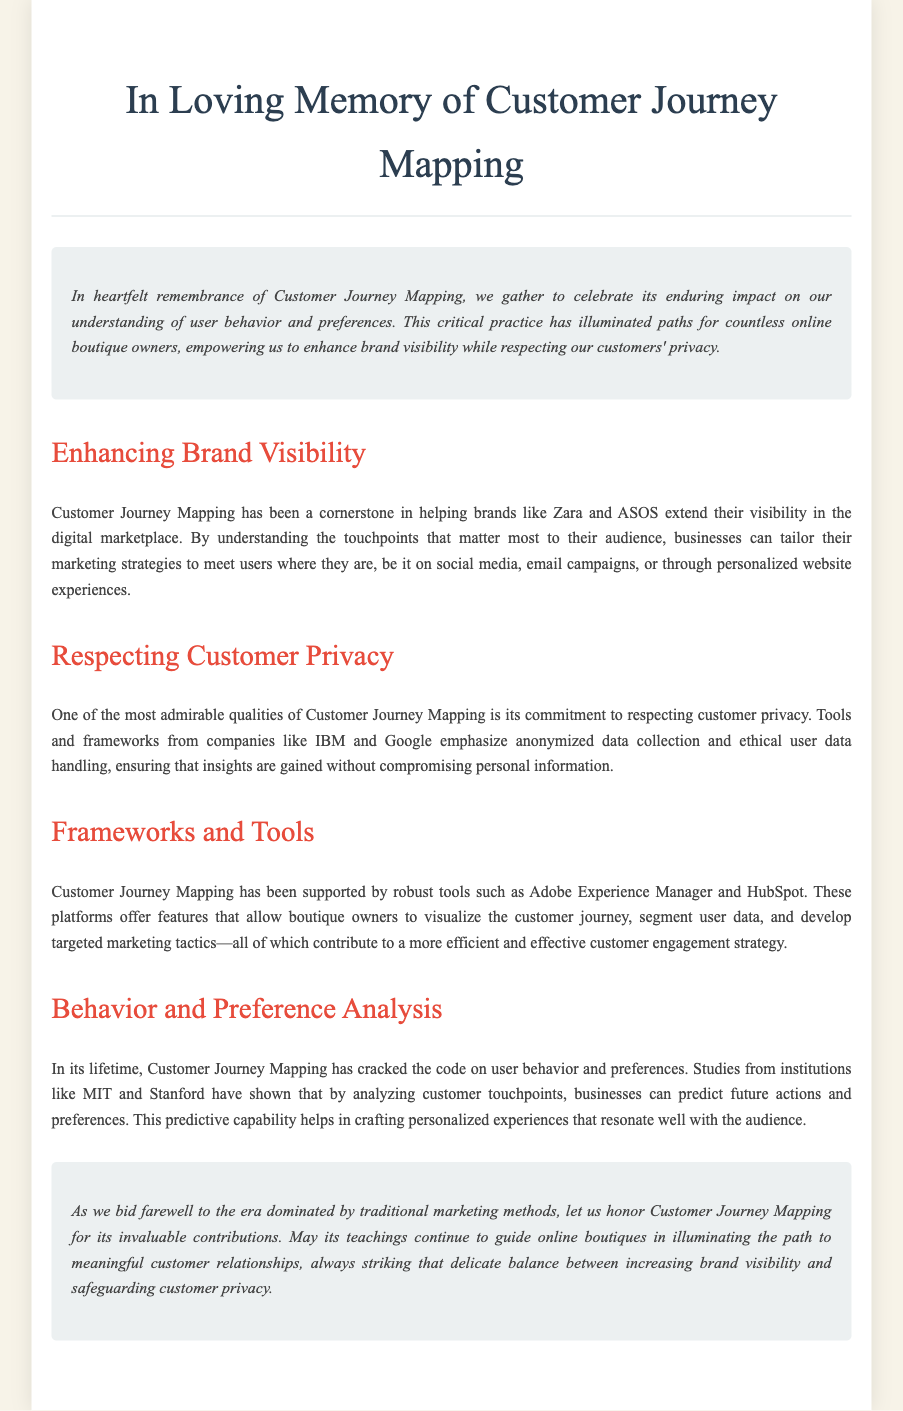what is the title of the document? The title of the document is displayed prominently at the top of the rendered content.
Answer: In Loving Memory of Customer Journey Mapping who are mentioned as companies that support Customer Journey Mapping? The document lists specific companies that play a role in Customer Journey Mapping, focusing on their contributions.
Answer: IBM and Google what is highlighted as a key aspect of Customer Journey Mapping? The text emphasizes the importance of respecting customer privacy as a major feature of Customer Journey Mapping.
Answer: Respecting customer privacy which platforms are mentioned that assist boutique owners? The document identifies specific platforms that provide tools and features for visualizing customer journeys.
Answer: Adobe Experience Manager and HubSpot what has Customer Journey Mapping helped businesses predict? The document discusses the analysis of user behavior and preferences enabled by Customer Journey Mapping.
Answer: Future actions and preferences what type of marketing methods does the document suggest has become less dominant? The conclusion reflects on the transition from traditional marketing methods to modern strategies.
Answer: Traditional marketing methods how does the document describe the impact of Customer Journey Mapping? The introduction provides insight into the lasting influence Customer Journey Mapping has had on online boutique owners.
Answer: Enduring impact on our understanding of user behavior and preferences who conducted studies mentioned in the document? The document references specific institutions that have contributed research related to analysis in Customer Journey Mapping.
Answer: MIT and Stanford what is the purpose of Customer Journey Mapping according to the document? The text encapsulates the ultimate goal of Customer Journey Mapping for businesses, notably boutique owners, in the context provided.
Answer: Illuminate the path to meaningful customer relationships 